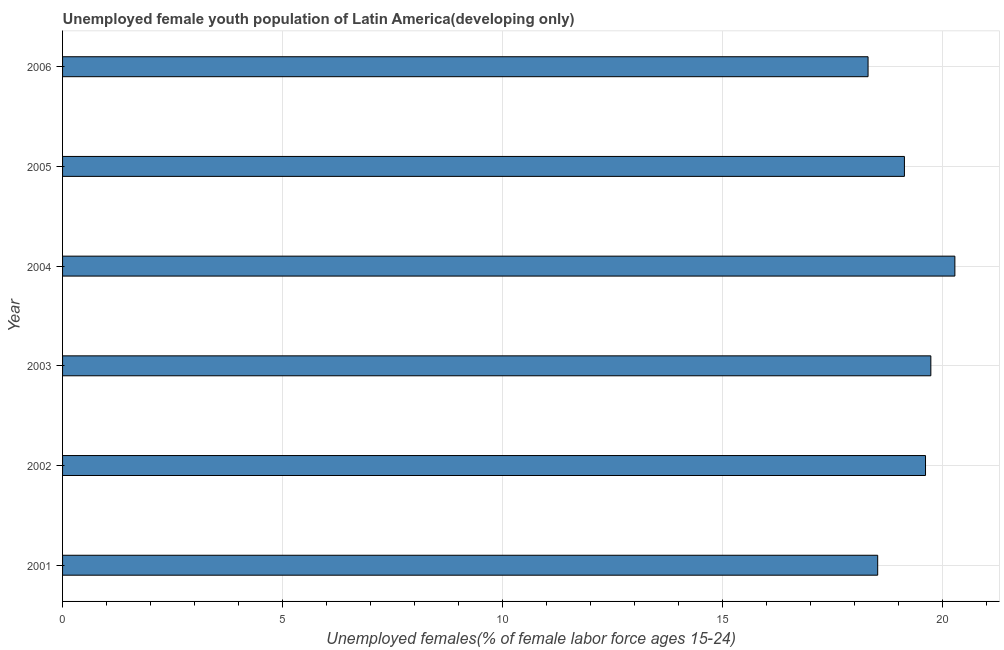What is the title of the graph?
Provide a short and direct response. Unemployed female youth population of Latin America(developing only). What is the label or title of the X-axis?
Your answer should be very brief. Unemployed females(% of female labor force ages 15-24). What is the unemployed female youth in 2002?
Provide a succinct answer. 19.62. Across all years, what is the maximum unemployed female youth?
Provide a short and direct response. 20.29. Across all years, what is the minimum unemployed female youth?
Make the answer very short. 18.31. In which year was the unemployed female youth maximum?
Your response must be concise. 2004. What is the sum of the unemployed female youth?
Provide a short and direct response. 115.63. What is the difference between the unemployed female youth in 2002 and 2004?
Provide a short and direct response. -0.67. What is the average unemployed female youth per year?
Offer a terse response. 19.27. What is the median unemployed female youth?
Your answer should be compact. 19.38. In how many years, is the unemployed female youth greater than 12 %?
Offer a very short reply. 6. Do a majority of the years between 2002 and 2001 (inclusive) have unemployed female youth greater than 9 %?
Make the answer very short. No. What is the difference between the highest and the second highest unemployed female youth?
Provide a succinct answer. 0.55. Is the sum of the unemployed female youth in 2002 and 2004 greater than the maximum unemployed female youth across all years?
Your response must be concise. Yes. What is the difference between the highest and the lowest unemployed female youth?
Provide a succinct answer. 1.97. In how many years, is the unemployed female youth greater than the average unemployed female youth taken over all years?
Offer a terse response. 3. Are all the bars in the graph horizontal?
Your response must be concise. Yes. What is the Unemployed females(% of female labor force ages 15-24) of 2001?
Make the answer very short. 18.53. What is the Unemployed females(% of female labor force ages 15-24) in 2002?
Provide a succinct answer. 19.62. What is the Unemployed females(% of female labor force ages 15-24) of 2003?
Your answer should be compact. 19.74. What is the Unemployed females(% of female labor force ages 15-24) in 2004?
Make the answer very short. 20.29. What is the Unemployed females(% of female labor force ages 15-24) of 2005?
Provide a short and direct response. 19.14. What is the Unemployed females(% of female labor force ages 15-24) in 2006?
Offer a very short reply. 18.31. What is the difference between the Unemployed females(% of female labor force ages 15-24) in 2001 and 2002?
Your response must be concise. -1.09. What is the difference between the Unemployed females(% of female labor force ages 15-24) in 2001 and 2003?
Offer a terse response. -1.21. What is the difference between the Unemployed females(% of female labor force ages 15-24) in 2001 and 2004?
Provide a short and direct response. -1.75. What is the difference between the Unemployed females(% of female labor force ages 15-24) in 2001 and 2005?
Make the answer very short. -0.61. What is the difference between the Unemployed females(% of female labor force ages 15-24) in 2001 and 2006?
Keep it short and to the point. 0.22. What is the difference between the Unemployed females(% of female labor force ages 15-24) in 2002 and 2003?
Make the answer very short. -0.12. What is the difference between the Unemployed females(% of female labor force ages 15-24) in 2002 and 2004?
Keep it short and to the point. -0.67. What is the difference between the Unemployed females(% of female labor force ages 15-24) in 2002 and 2005?
Ensure brevity in your answer.  0.48. What is the difference between the Unemployed females(% of female labor force ages 15-24) in 2002 and 2006?
Keep it short and to the point. 1.31. What is the difference between the Unemployed females(% of female labor force ages 15-24) in 2003 and 2004?
Provide a succinct answer. -0.55. What is the difference between the Unemployed females(% of female labor force ages 15-24) in 2003 and 2005?
Provide a short and direct response. 0.6. What is the difference between the Unemployed females(% of female labor force ages 15-24) in 2003 and 2006?
Offer a very short reply. 1.43. What is the difference between the Unemployed females(% of female labor force ages 15-24) in 2004 and 2005?
Your answer should be very brief. 1.15. What is the difference between the Unemployed females(% of female labor force ages 15-24) in 2004 and 2006?
Your answer should be very brief. 1.97. What is the difference between the Unemployed females(% of female labor force ages 15-24) in 2005 and 2006?
Your answer should be very brief. 0.83. What is the ratio of the Unemployed females(% of female labor force ages 15-24) in 2001 to that in 2002?
Offer a very short reply. 0.94. What is the ratio of the Unemployed females(% of female labor force ages 15-24) in 2001 to that in 2003?
Your response must be concise. 0.94. What is the ratio of the Unemployed females(% of female labor force ages 15-24) in 2002 to that in 2005?
Keep it short and to the point. 1.02. What is the ratio of the Unemployed females(% of female labor force ages 15-24) in 2002 to that in 2006?
Your answer should be compact. 1.07. What is the ratio of the Unemployed females(% of female labor force ages 15-24) in 2003 to that in 2004?
Offer a very short reply. 0.97. What is the ratio of the Unemployed females(% of female labor force ages 15-24) in 2003 to that in 2005?
Provide a short and direct response. 1.03. What is the ratio of the Unemployed females(% of female labor force ages 15-24) in 2003 to that in 2006?
Your answer should be compact. 1.08. What is the ratio of the Unemployed females(% of female labor force ages 15-24) in 2004 to that in 2005?
Your response must be concise. 1.06. What is the ratio of the Unemployed females(% of female labor force ages 15-24) in 2004 to that in 2006?
Your answer should be very brief. 1.11. What is the ratio of the Unemployed females(% of female labor force ages 15-24) in 2005 to that in 2006?
Ensure brevity in your answer.  1.04. 